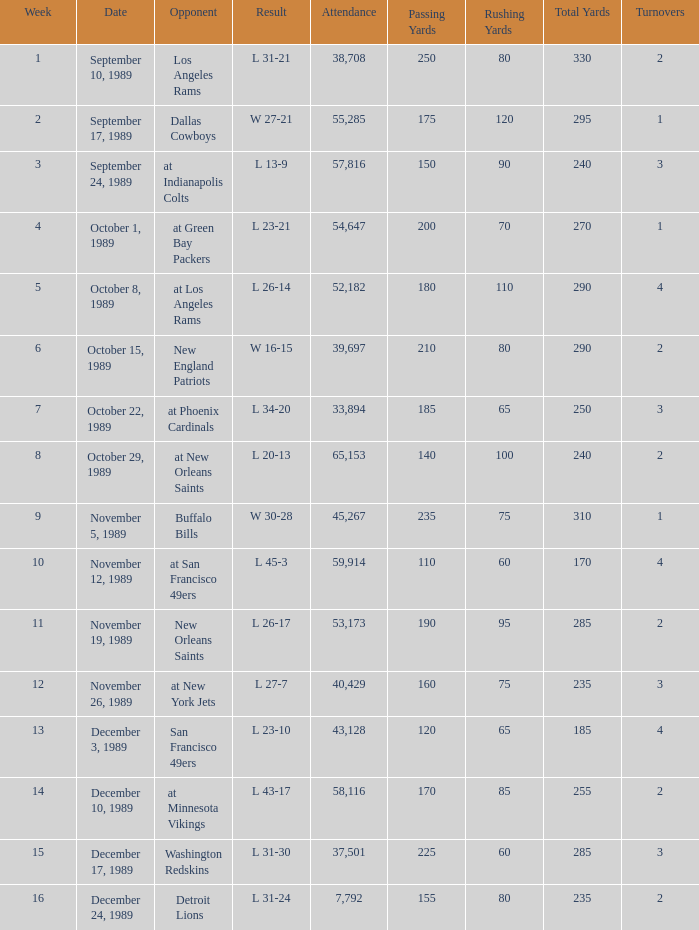The Detroit Lions were played against what week? 16.0. 